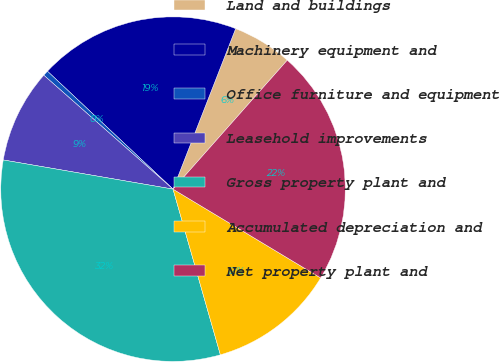Convert chart to OTSL. <chart><loc_0><loc_0><loc_500><loc_500><pie_chart><fcel>Land and buildings<fcel>Machinery equipment and<fcel>Office furniture and equipment<fcel>Leasehold improvements<fcel>Gross property plant and<fcel>Accumulated depreciation and<fcel>Net property plant and<nl><fcel>5.62%<fcel>18.92%<fcel>0.5%<fcel>8.79%<fcel>32.14%<fcel>11.95%<fcel>22.08%<nl></chart> 